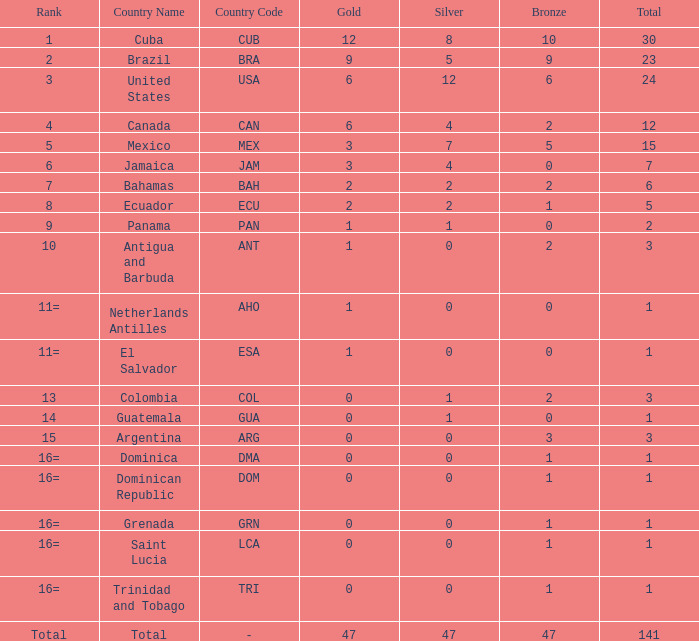What is the average silver with more than 0 gold, a Rank of 1, and a Total smaller than 30? None. 